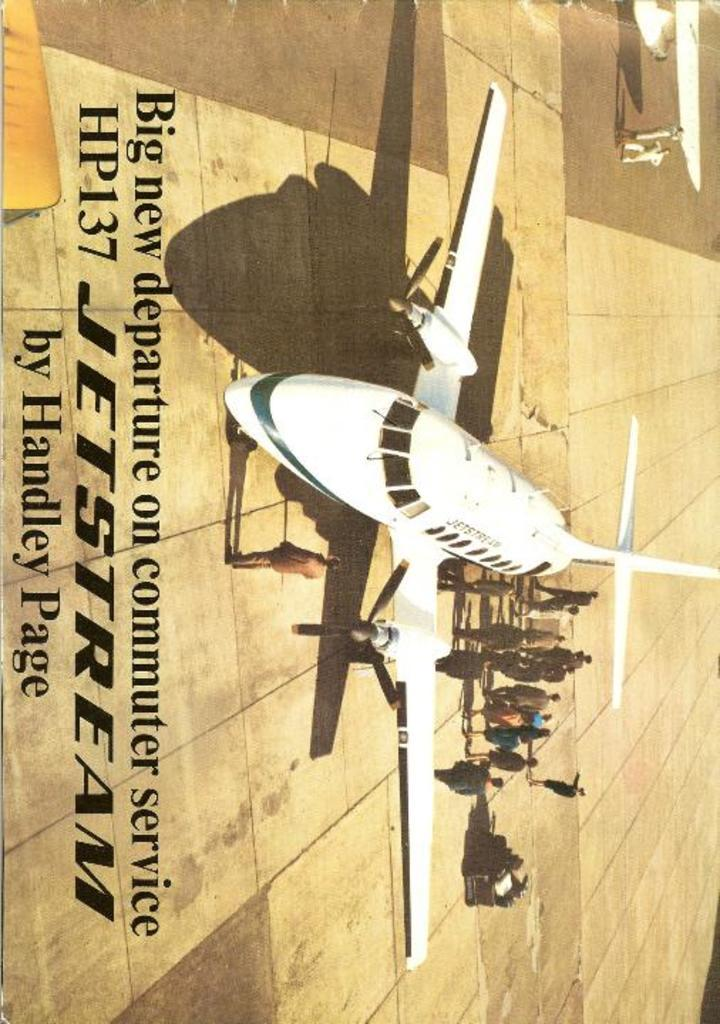What is the main subject of the image? The main subject of the image is an airplane. Can you describe the color of the airplane? The airplane is white. What else can be seen in the image besides the airplane? There are people with different color dresses in the image. Is there any text or writing visible in the image? Yes, there is text or writing visible to the left of the image. How many seats are available for passengers in the airplane in the image? There is no information about the number of seats in the airplane in the image. What type of suit is the person wearing in the image? There is no person wearing a suit in the image. 